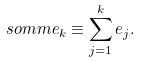Convert formula to latex. <formula><loc_0><loc_0><loc_500><loc_500>\ s o m m e _ { k } \equiv \sum _ { j = 1 } ^ { k } e _ { j } .</formula> 